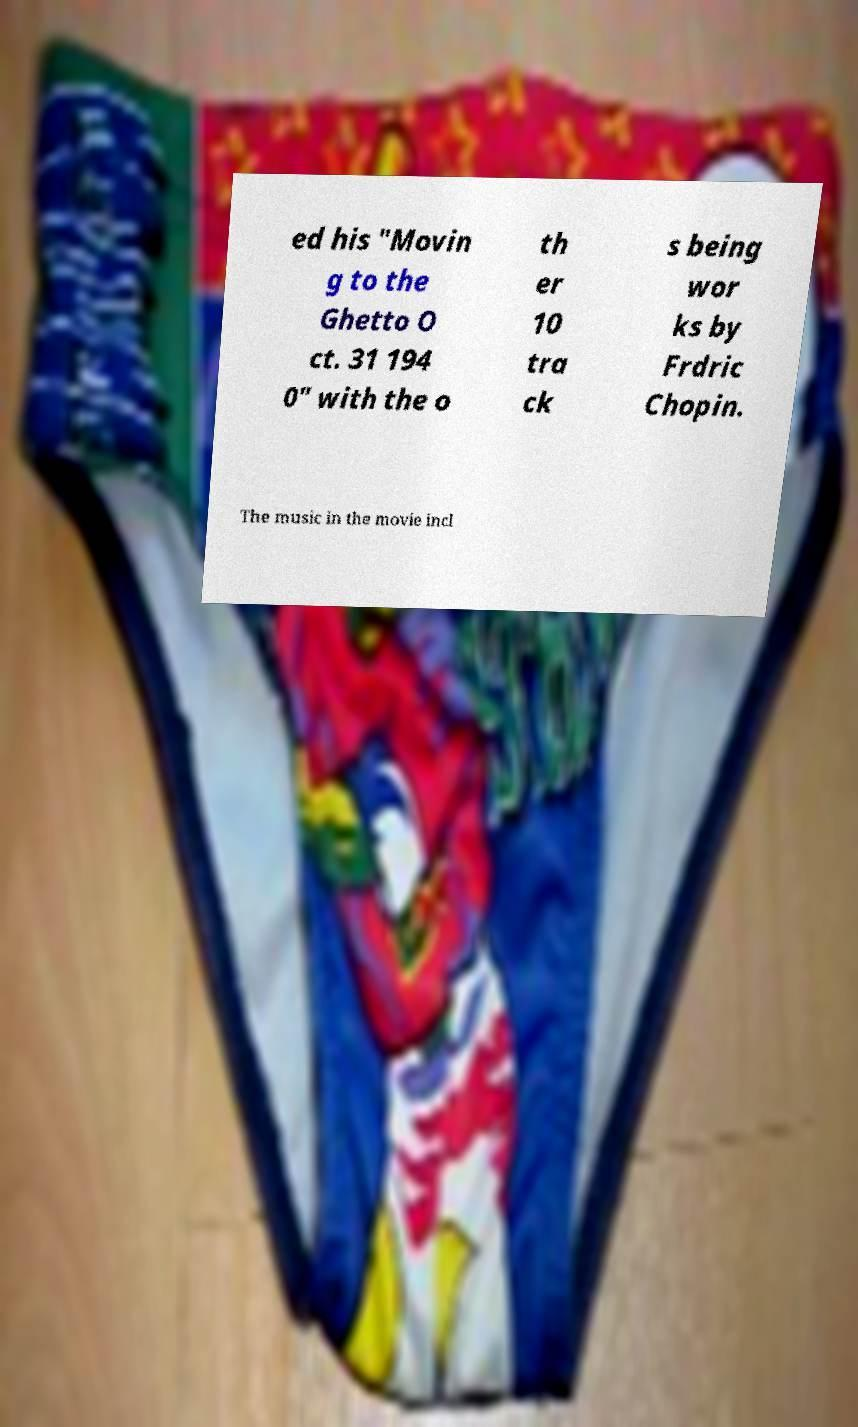Please identify and transcribe the text found in this image. ed his "Movin g to the Ghetto O ct. 31 194 0" with the o th er 10 tra ck s being wor ks by Frdric Chopin. The music in the movie incl 